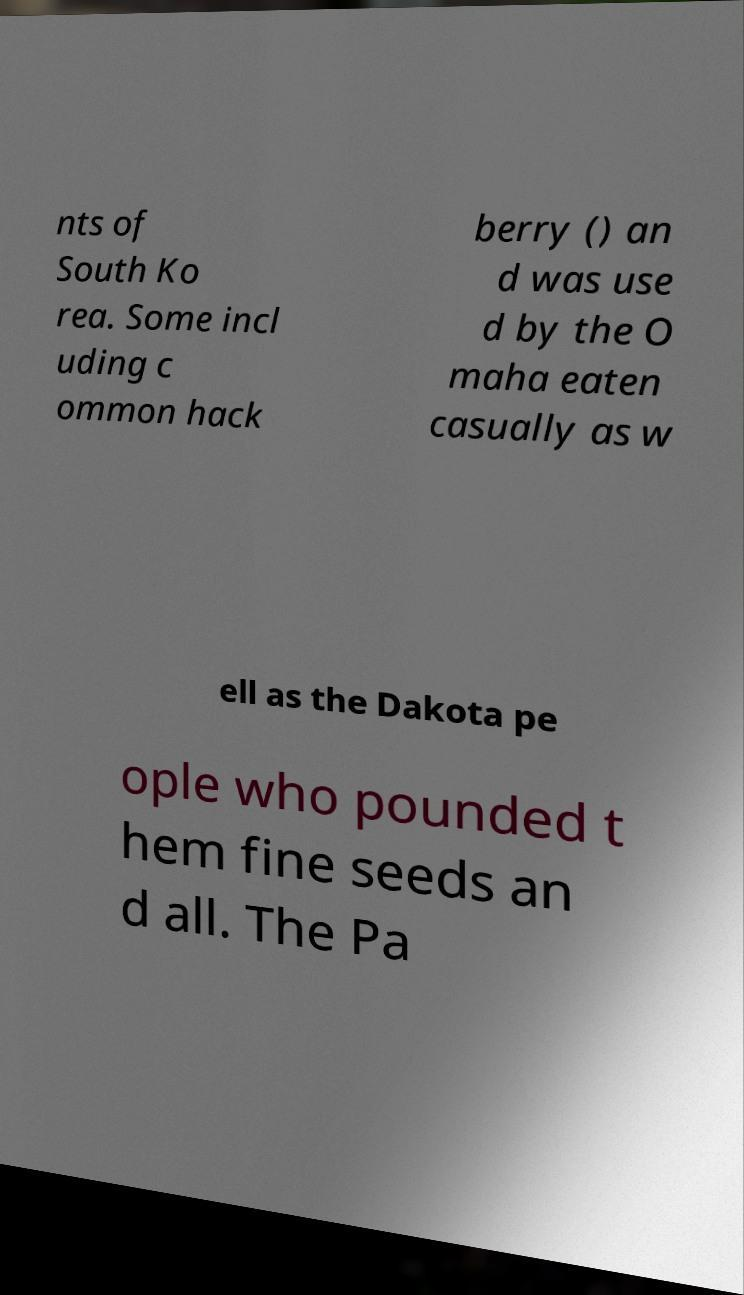Can you read and provide the text displayed in the image?This photo seems to have some interesting text. Can you extract and type it out for me? nts of South Ko rea. Some incl uding c ommon hack berry () an d was use d by the O maha eaten casually as w ell as the Dakota pe ople who pounded t hem fine seeds an d all. The Pa 